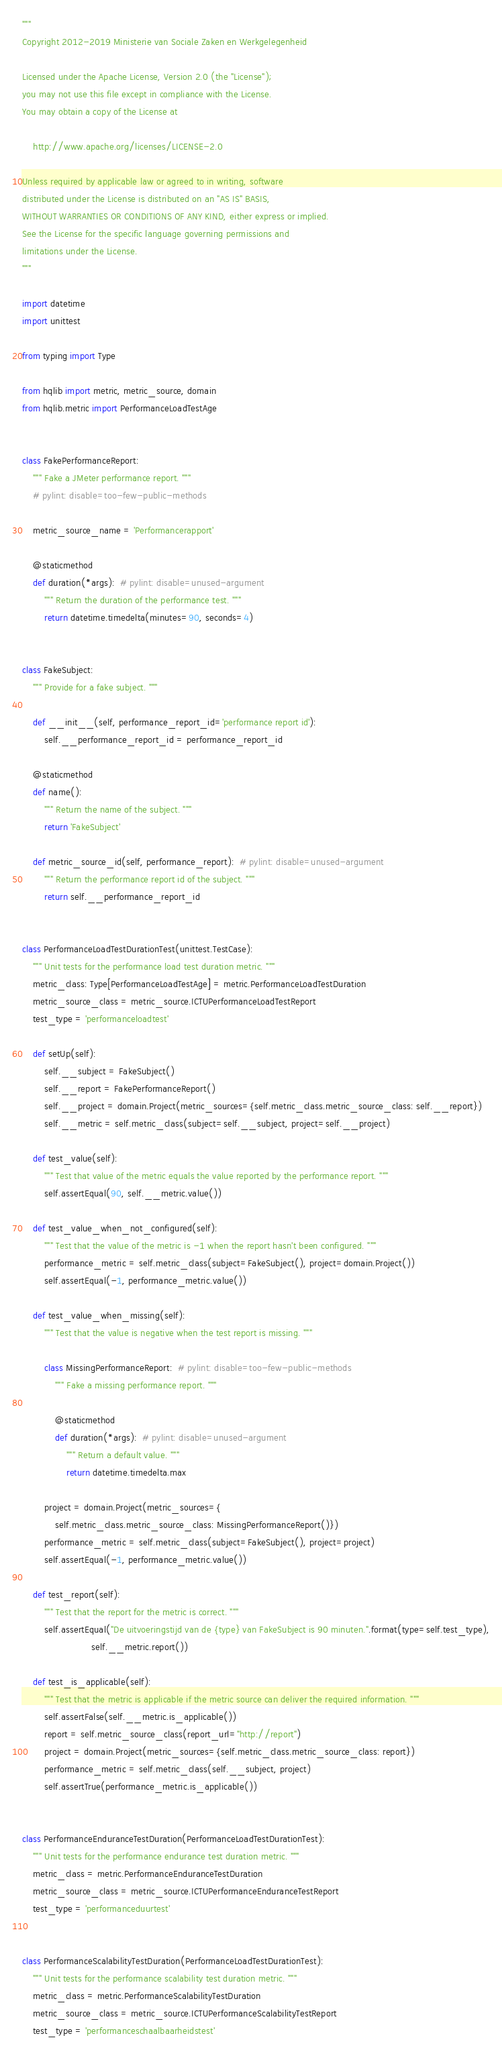Convert code to text. <code><loc_0><loc_0><loc_500><loc_500><_Python_>"""
Copyright 2012-2019 Ministerie van Sociale Zaken en Werkgelegenheid

Licensed under the Apache License, Version 2.0 (the "License");
you may not use this file except in compliance with the License.
You may obtain a copy of the License at

    http://www.apache.org/licenses/LICENSE-2.0

Unless required by applicable law or agreed to in writing, software
distributed under the License is distributed on an "AS IS" BASIS,
WITHOUT WARRANTIES OR CONDITIONS OF ANY KIND, either express or implied.
See the License for the specific language governing permissions and
limitations under the License.
"""

import datetime
import unittest

from typing import Type

from hqlib import metric, metric_source, domain
from hqlib.metric import PerformanceLoadTestAge


class FakePerformanceReport:
    """ Fake a JMeter performance report. """
    # pylint: disable=too-few-public-methods

    metric_source_name = 'Performancerapport'

    @staticmethod
    def duration(*args):  # pylint: disable=unused-argument
        """ Return the duration of the performance test. """
        return datetime.timedelta(minutes=90, seconds=4)


class FakeSubject:
    """ Provide for a fake subject. """

    def __init__(self, performance_report_id='performance report id'):
        self.__performance_report_id = performance_report_id

    @staticmethod
    def name():
        """ Return the name of the subject. """
        return 'FakeSubject'

    def metric_source_id(self, performance_report):  # pylint: disable=unused-argument
        """ Return the performance report id of the subject. """
        return self.__performance_report_id


class PerformanceLoadTestDurationTest(unittest.TestCase):
    """ Unit tests for the performance load test duration metric. """
    metric_class: Type[PerformanceLoadTestAge] = metric.PerformanceLoadTestDuration
    metric_source_class = metric_source.ICTUPerformanceLoadTestReport
    test_type = 'performanceloadtest'

    def setUp(self):
        self.__subject = FakeSubject()
        self.__report = FakePerformanceReport()
        self.__project = domain.Project(metric_sources={self.metric_class.metric_source_class: self.__report})
        self.__metric = self.metric_class(subject=self.__subject, project=self.__project)

    def test_value(self):
        """ Test that value of the metric equals the value reported by the performance report. """
        self.assertEqual(90, self.__metric.value())

    def test_value_when_not_configured(self):
        """ Test that the value of the metric is -1 when the report hasn't been configured. """
        performance_metric = self.metric_class(subject=FakeSubject(), project=domain.Project())
        self.assertEqual(-1, performance_metric.value())

    def test_value_when_missing(self):
        """ Test that the value is negative when the test report is missing. """

        class MissingPerformanceReport:  # pylint: disable=too-few-public-methods
            """ Fake a missing performance report. """

            @staticmethod
            def duration(*args):  # pylint: disable=unused-argument
                """ Return a default value. """
                return datetime.timedelta.max

        project = domain.Project(metric_sources={
            self.metric_class.metric_source_class: MissingPerformanceReport()})
        performance_metric = self.metric_class(subject=FakeSubject(), project=project)
        self.assertEqual(-1, performance_metric.value())

    def test_report(self):
        """ Test that the report for the metric is correct. """
        self.assertEqual("De uitvoeringstijd van de {type} van FakeSubject is 90 minuten.".format(type=self.test_type),
                         self.__metric.report())

    def test_is_applicable(self):
        """ Test that the metric is applicable if the metric source can deliver the required information. """
        self.assertFalse(self.__metric.is_applicable())
        report = self.metric_source_class(report_url="http://report")
        project = domain.Project(metric_sources={self.metric_class.metric_source_class: report})
        performance_metric = self.metric_class(self.__subject, project)
        self.assertTrue(performance_metric.is_applicable())


class PerformanceEnduranceTestDuration(PerformanceLoadTestDurationTest):
    """ Unit tests for the performance endurance test duration metric. """
    metric_class = metric.PerformanceEnduranceTestDuration
    metric_source_class = metric_source.ICTUPerformanceEnduranceTestReport
    test_type = 'performanceduurtest'


class PerformanceScalabilityTestDuration(PerformanceLoadTestDurationTest):
    """ Unit tests for the performance scalability test duration metric. """
    metric_class = metric.PerformanceScalabilityTestDuration
    metric_source_class = metric_source.ICTUPerformanceScalabilityTestReport
    test_type = 'performanceschaalbaarheidstest'
</code> 